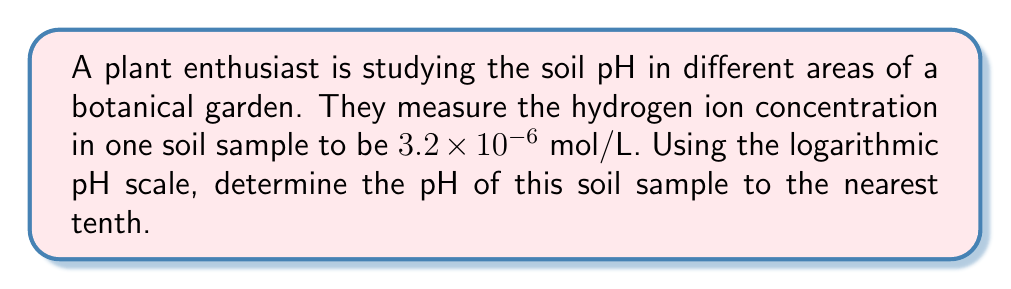Teach me how to tackle this problem. Let's approach this step-by-step:

1) The pH scale is defined as the negative logarithm (base 10) of the hydrogen ion concentration [H+] in mol/L:

   $$ pH = -\log_{10}[H^+] $$

2) We're given that the hydrogen ion concentration is $3.2 \times 10^{-6}$ mol/L.

3) Let's substitute this into our equation:

   $$ pH = -\log_{10}(3.2 \times 10^{-6}) $$

4) To solve this, we can use the properties of logarithms. Specifically:

   $$ \log(a \times 10^n) = \log(a) + n $$

5) Applying this to our problem:

   $$ pH = -(\log_{10}(3.2) + \log_{10}(10^{-6})) $$

6) We know that $\log_{10}(10^{-6}) = -6$, so:

   $$ pH = -(\log_{10}(3.2) - 6) $$

7) Using a calculator or logarithm table, we can find that $\log_{10}(3.2) \approx 0.5051$

8) Substituting this in:

   $$ pH = -(0.5051 - 6) = -0.5051 + 6 = 5.4949 $$

9) Rounding to the nearest tenth as requested:

   $$ pH \approx 5.5 $$

This pH indicates that the soil is slightly acidic, which could be beneficial for certain plant species that thrive in such conditions.
Answer: 5.5 